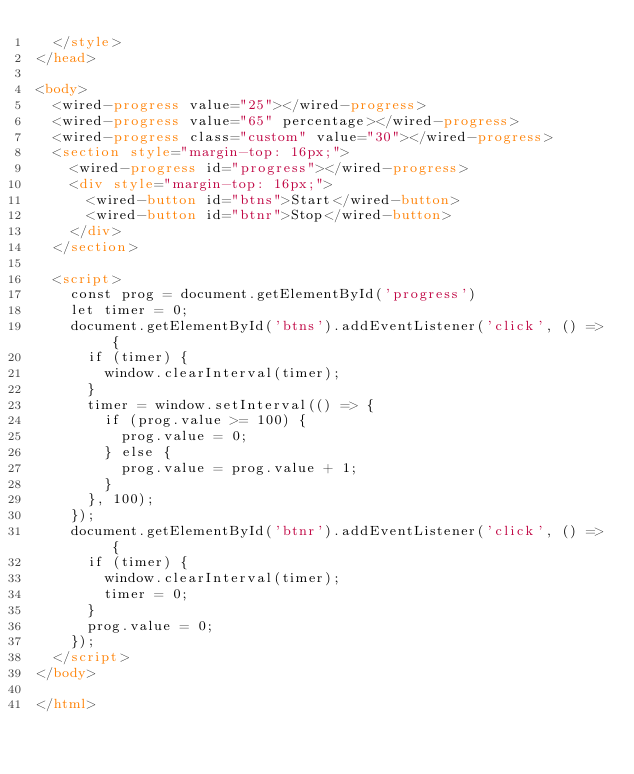<code> <loc_0><loc_0><loc_500><loc_500><_HTML_>  </style>
</head>

<body>
  <wired-progress value="25"></wired-progress>
  <wired-progress value="65" percentage></wired-progress>
  <wired-progress class="custom" value="30"></wired-progress>
  <section style="margin-top: 16px;">
    <wired-progress id="progress"></wired-progress>
    <div style="margin-top: 16px;">
      <wired-button id="btns">Start</wired-button>
      <wired-button id="btnr">Stop</wired-button>
    </div>
  </section>

  <script>
    const prog = document.getElementById('progress')
    let timer = 0;
    document.getElementById('btns').addEventListener('click', () => {
      if (timer) {
        window.clearInterval(timer);
      }
      timer = window.setInterval(() => {
        if (prog.value >= 100) {
          prog.value = 0;
        } else {
          prog.value = prog.value + 1;
        }
      }, 100);
    });
    document.getElementById('btnr').addEventListener('click', () => {
      if (timer) {
        window.clearInterval(timer);
        timer = 0;
      }
      prog.value = 0;
    });
  </script>
</body>

</html></code> 